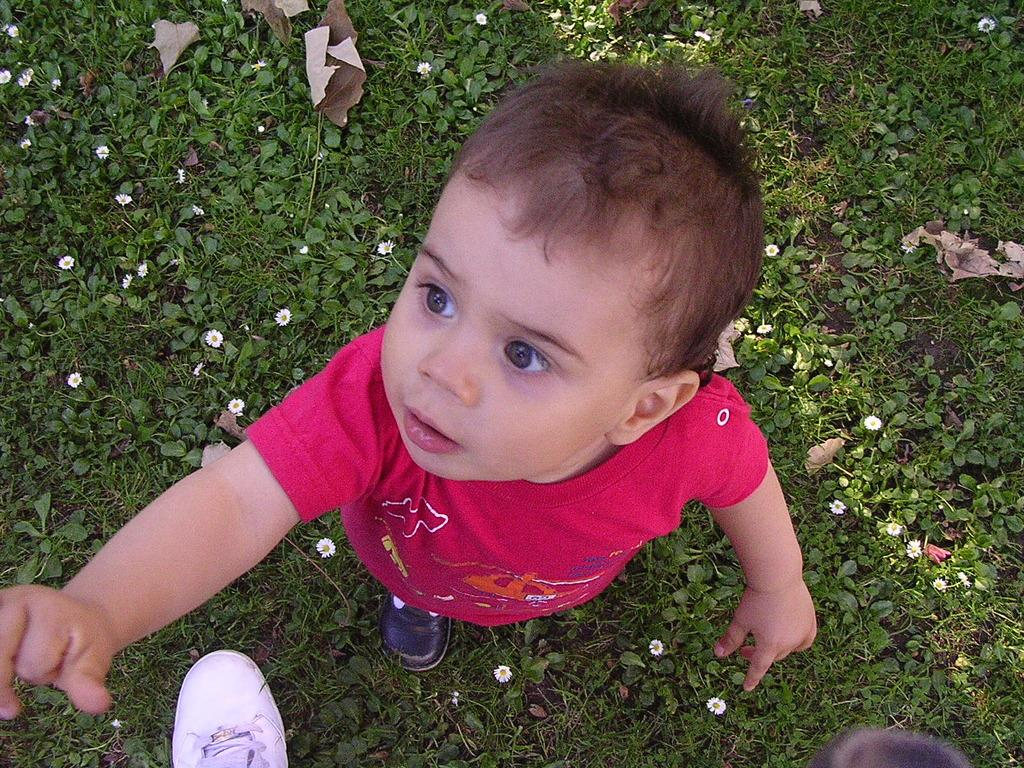What is the kid doing in the image? The kid is standing on the ground in the image. What type of vegetation is present in the image? There are plants with flowers in the image. Can you describe any objects near the kid? There is a shoe near the kid. What type of noise can be heard coming from the duck in the image? There is no duck present in the image, so no noise can be heard from a duck. How many dolls are visible in the image? There are no dolls present in the image. 